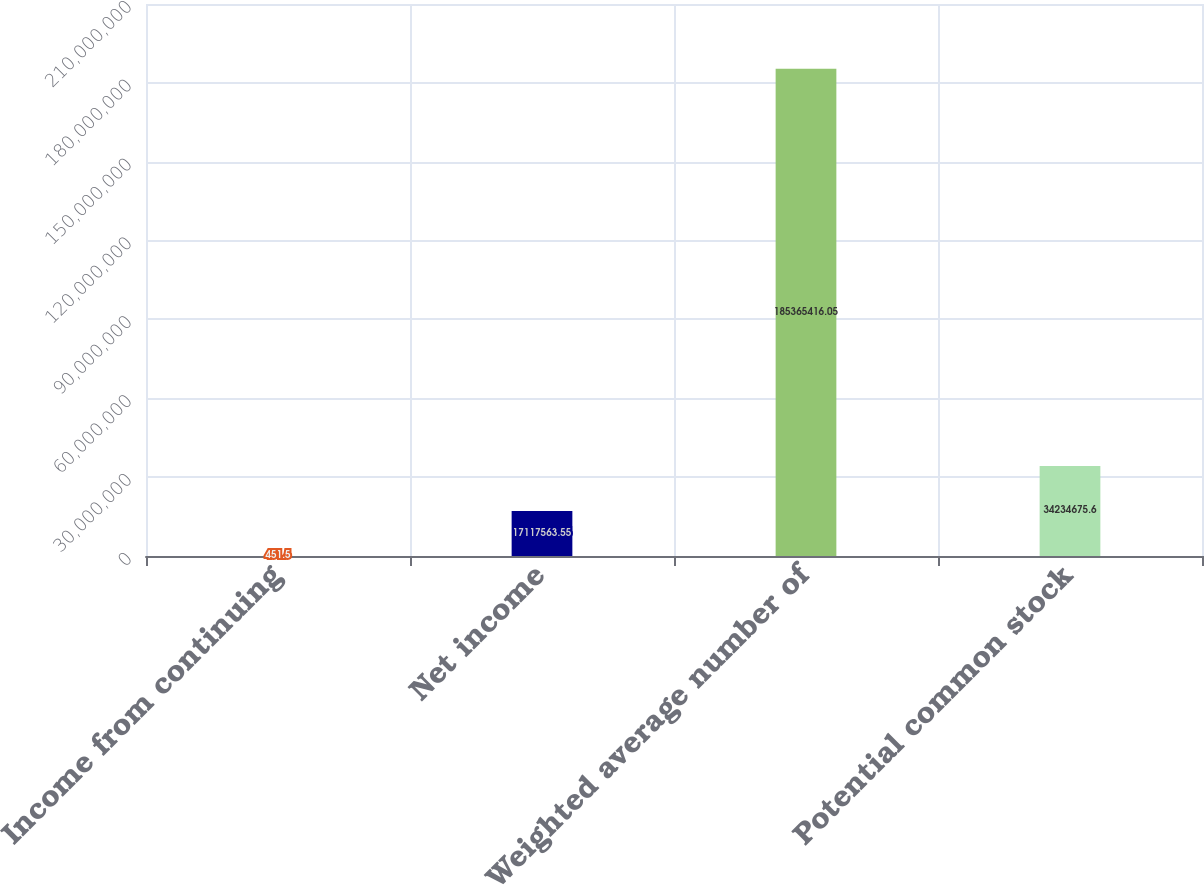Convert chart. <chart><loc_0><loc_0><loc_500><loc_500><bar_chart><fcel>Income from continuing<fcel>Net income<fcel>Weighted average number of<fcel>Potential common stock<nl><fcel>451.5<fcel>1.71176e+07<fcel>1.85365e+08<fcel>3.42347e+07<nl></chart> 